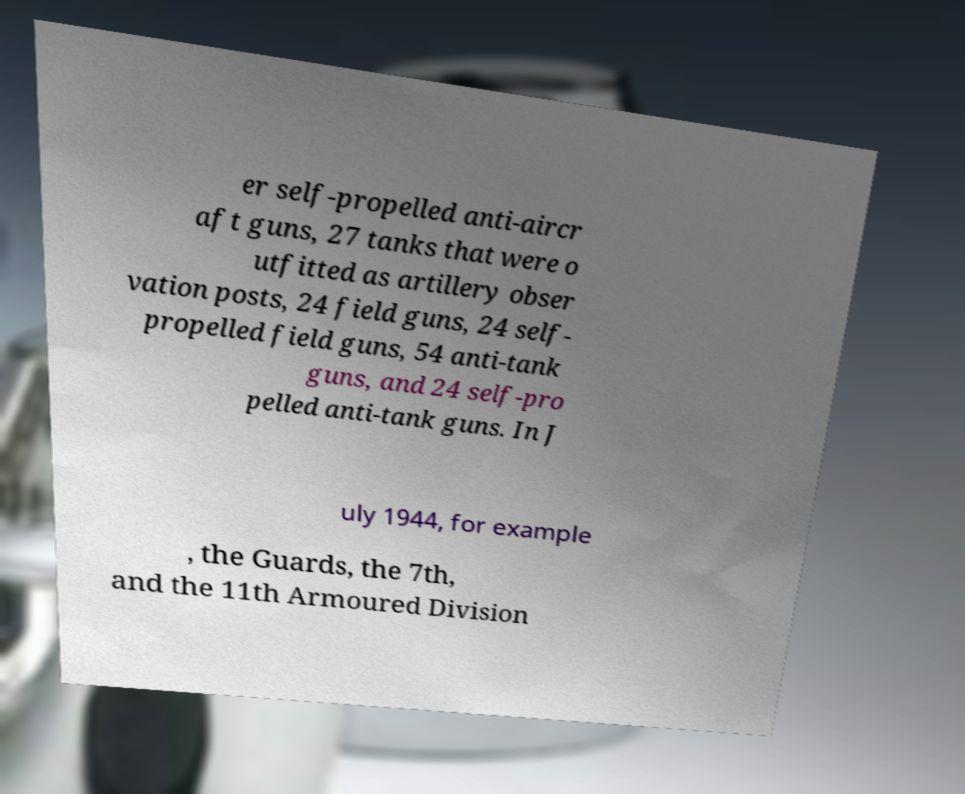Please read and relay the text visible in this image. What does it say? er self-propelled anti-aircr aft guns, 27 tanks that were o utfitted as artillery obser vation posts, 24 field guns, 24 self- propelled field guns, 54 anti-tank guns, and 24 self-pro pelled anti-tank guns. In J uly 1944, for example , the Guards, the 7th, and the 11th Armoured Division 